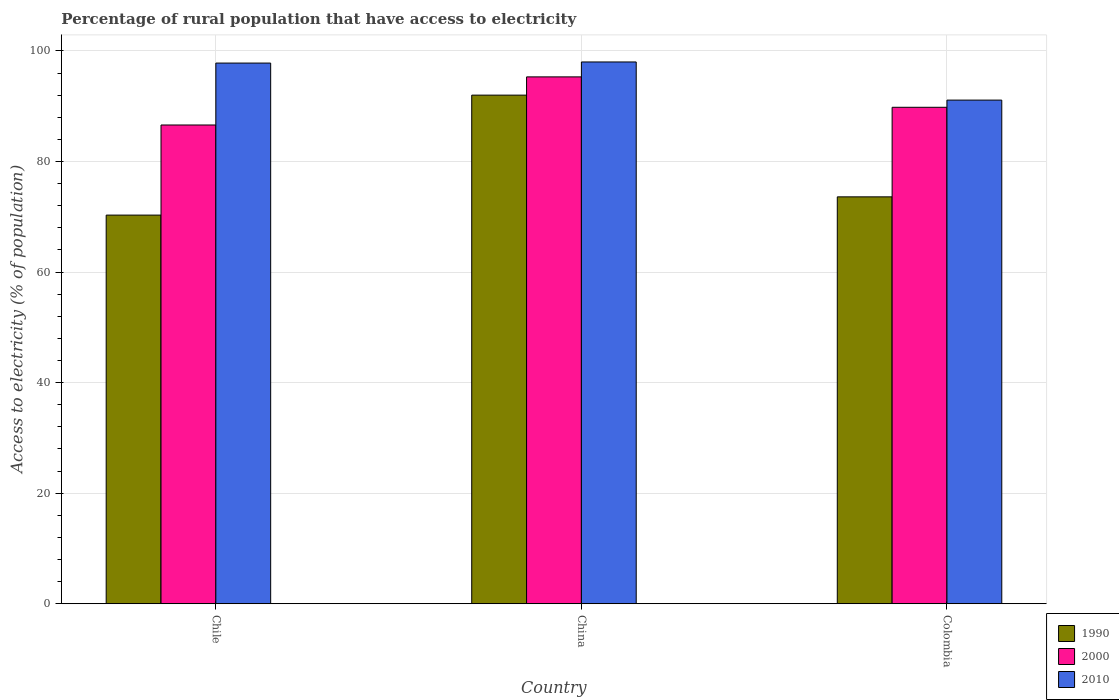How many different coloured bars are there?
Provide a short and direct response. 3. Are the number of bars per tick equal to the number of legend labels?
Your response must be concise. Yes. What is the label of the 2nd group of bars from the left?
Your answer should be very brief. China. In how many cases, is the number of bars for a given country not equal to the number of legend labels?
Ensure brevity in your answer.  0. What is the percentage of rural population that have access to electricity in 1990 in China?
Keep it short and to the point. 92. Across all countries, what is the maximum percentage of rural population that have access to electricity in 1990?
Keep it short and to the point. 92. Across all countries, what is the minimum percentage of rural population that have access to electricity in 2000?
Your response must be concise. 86.6. What is the total percentage of rural population that have access to electricity in 2000 in the graph?
Give a very brief answer. 271.7. What is the difference between the percentage of rural population that have access to electricity in 2010 in China and that in Colombia?
Offer a terse response. 6.9. What is the difference between the percentage of rural population that have access to electricity in 1990 in Chile and the percentage of rural population that have access to electricity in 2000 in China?
Your response must be concise. -25. What is the average percentage of rural population that have access to electricity in 2010 per country?
Keep it short and to the point. 95.63. What is the difference between the percentage of rural population that have access to electricity of/in 2010 and percentage of rural population that have access to electricity of/in 2000 in Chile?
Your answer should be compact. 11.2. In how many countries, is the percentage of rural population that have access to electricity in 2010 greater than 28 %?
Give a very brief answer. 3. What is the ratio of the percentage of rural population that have access to electricity in 2000 in Chile to that in Colombia?
Your answer should be very brief. 0.96. Is the percentage of rural population that have access to electricity in 1990 in China less than that in Colombia?
Offer a very short reply. No. Is the difference between the percentage of rural population that have access to electricity in 2010 in Chile and China greater than the difference between the percentage of rural population that have access to electricity in 2000 in Chile and China?
Offer a terse response. Yes. What is the difference between the highest and the second highest percentage of rural population that have access to electricity in 2010?
Provide a short and direct response. -0.2. What is the difference between the highest and the lowest percentage of rural population that have access to electricity in 1990?
Your answer should be compact. 21.7. In how many countries, is the percentage of rural population that have access to electricity in 1990 greater than the average percentage of rural population that have access to electricity in 1990 taken over all countries?
Make the answer very short. 1. What does the 1st bar from the left in Chile represents?
Your answer should be compact. 1990. What does the 1st bar from the right in Chile represents?
Provide a short and direct response. 2010. Is it the case that in every country, the sum of the percentage of rural population that have access to electricity in 1990 and percentage of rural population that have access to electricity in 2010 is greater than the percentage of rural population that have access to electricity in 2000?
Your response must be concise. Yes. How many bars are there?
Provide a short and direct response. 9. Does the graph contain any zero values?
Your answer should be very brief. No. Where does the legend appear in the graph?
Ensure brevity in your answer.  Bottom right. How many legend labels are there?
Ensure brevity in your answer.  3. What is the title of the graph?
Give a very brief answer. Percentage of rural population that have access to electricity. What is the label or title of the X-axis?
Your answer should be very brief. Country. What is the label or title of the Y-axis?
Keep it short and to the point. Access to electricity (% of population). What is the Access to electricity (% of population) of 1990 in Chile?
Provide a succinct answer. 70.3. What is the Access to electricity (% of population) in 2000 in Chile?
Ensure brevity in your answer.  86.6. What is the Access to electricity (% of population) in 2010 in Chile?
Make the answer very short. 97.8. What is the Access to electricity (% of population) of 1990 in China?
Provide a short and direct response. 92. What is the Access to electricity (% of population) in 2000 in China?
Your response must be concise. 95.3. What is the Access to electricity (% of population) in 1990 in Colombia?
Provide a short and direct response. 73.6. What is the Access to electricity (% of population) of 2000 in Colombia?
Offer a terse response. 89.8. What is the Access to electricity (% of population) of 2010 in Colombia?
Ensure brevity in your answer.  91.1. Across all countries, what is the maximum Access to electricity (% of population) in 1990?
Give a very brief answer. 92. Across all countries, what is the maximum Access to electricity (% of population) of 2000?
Make the answer very short. 95.3. Across all countries, what is the minimum Access to electricity (% of population) in 1990?
Provide a succinct answer. 70.3. Across all countries, what is the minimum Access to electricity (% of population) of 2000?
Your response must be concise. 86.6. Across all countries, what is the minimum Access to electricity (% of population) in 2010?
Your answer should be compact. 91.1. What is the total Access to electricity (% of population) of 1990 in the graph?
Your response must be concise. 235.9. What is the total Access to electricity (% of population) of 2000 in the graph?
Your answer should be compact. 271.7. What is the total Access to electricity (% of population) in 2010 in the graph?
Offer a very short reply. 286.9. What is the difference between the Access to electricity (% of population) of 1990 in Chile and that in China?
Your response must be concise. -21.7. What is the difference between the Access to electricity (% of population) in 2000 in Chile and that in China?
Your answer should be compact. -8.7. What is the difference between the Access to electricity (% of population) of 2010 in Chile and that in China?
Provide a short and direct response. -0.2. What is the difference between the Access to electricity (% of population) in 2000 in Chile and that in Colombia?
Make the answer very short. -3.2. What is the difference between the Access to electricity (% of population) in 1990 in China and that in Colombia?
Your answer should be very brief. 18.4. What is the difference between the Access to electricity (% of population) of 2000 in China and that in Colombia?
Offer a terse response. 5.5. What is the difference between the Access to electricity (% of population) of 2010 in China and that in Colombia?
Provide a short and direct response. 6.9. What is the difference between the Access to electricity (% of population) of 1990 in Chile and the Access to electricity (% of population) of 2000 in China?
Provide a short and direct response. -25. What is the difference between the Access to electricity (% of population) in 1990 in Chile and the Access to electricity (% of population) in 2010 in China?
Your response must be concise. -27.7. What is the difference between the Access to electricity (% of population) of 2000 in Chile and the Access to electricity (% of population) of 2010 in China?
Keep it short and to the point. -11.4. What is the difference between the Access to electricity (% of population) in 1990 in Chile and the Access to electricity (% of population) in 2000 in Colombia?
Your answer should be compact. -19.5. What is the difference between the Access to electricity (% of population) of 1990 in Chile and the Access to electricity (% of population) of 2010 in Colombia?
Keep it short and to the point. -20.8. What is the difference between the Access to electricity (% of population) in 1990 in China and the Access to electricity (% of population) in 2000 in Colombia?
Provide a succinct answer. 2.2. What is the difference between the Access to electricity (% of population) of 1990 in China and the Access to electricity (% of population) of 2010 in Colombia?
Keep it short and to the point. 0.9. What is the difference between the Access to electricity (% of population) in 2000 in China and the Access to electricity (% of population) in 2010 in Colombia?
Your answer should be compact. 4.2. What is the average Access to electricity (% of population) in 1990 per country?
Give a very brief answer. 78.63. What is the average Access to electricity (% of population) in 2000 per country?
Provide a succinct answer. 90.57. What is the average Access to electricity (% of population) of 2010 per country?
Make the answer very short. 95.63. What is the difference between the Access to electricity (% of population) of 1990 and Access to electricity (% of population) of 2000 in Chile?
Offer a terse response. -16.3. What is the difference between the Access to electricity (% of population) in 1990 and Access to electricity (% of population) in 2010 in Chile?
Your answer should be compact. -27.5. What is the difference between the Access to electricity (% of population) in 2000 and Access to electricity (% of population) in 2010 in China?
Give a very brief answer. -2.7. What is the difference between the Access to electricity (% of population) of 1990 and Access to electricity (% of population) of 2000 in Colombia?
Make the answer very short. -16.2. What is the difference between the Access to electricity (% of population) of 1990 and Access to electricity (% of population) of 2010 in Colombia?
Keep it short and to the point. -17.5. What is the ratio of the Access to electricity (% of population) of 1990 in Chile to that in China?
Keep it short and to the point. 0.76. What is the ratio of the Access to electricity (% of population) of 2000 in Chile to that in China?
Provide a short and direct response. 0.91. What is the ratio of the Access to electricity (% of population) of 2010 in Chile to that in China?
Provide a short and direct response. 1. What is the ratio of the Access to electricity (% of population) of 1990 in Chile to that in Colombia?
Ensure brevity in your answer.  0.96. What is the ratio of the Access to electricity (% of population) in 2000 in Chile to that in Colombia?
Your answer should be compact. 0.96. What is the ratio of the Access to electricity (% of population) in 2010 in Chile to that in Colombia?
Make the answer very short. 1.07. What is the ratio of the Access to electricity (% of population) in 2000 in China to that in Colombia?
Your answer should be compact. 1.06. What is the ratio of the Access to electricity (% of population) in 2010 in China to that in Colombia?
Provide a succinct answer. 1.08. What is the difference between the highest and the second highest Access to electricity (% of population) in 1990?
Your answer should be compact. 18.4. What is the difference between the highest and the second highest Access to electricity (% of population) of 2000?
Give a very brief answer. 5.5. What is the difference between the highest and the second highest Access to electricity (% of population) of 2010?
Provide a succinct answer. 0.2. What is the difference between the highest and the lowest Access to electricity (% of population) of 1990?
Offer a terse response. 21.7. What is the difference between the highest and the lowest Access to electricity (% of population) in 2000?
Keep it short and to the point. 8.7. 